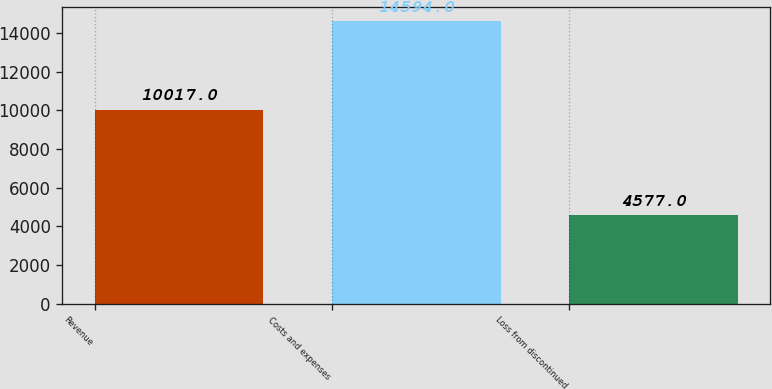Convert chart to OTSL. <chart><loc_0><loc_0><loc_500><loc_500><bar_chart><fcel>Revenue<fcel>Costs and expenses<fcel>Loss from discontinued<nl><fcel>10017<fcel>14594<fcel>4577<nl></chart> 